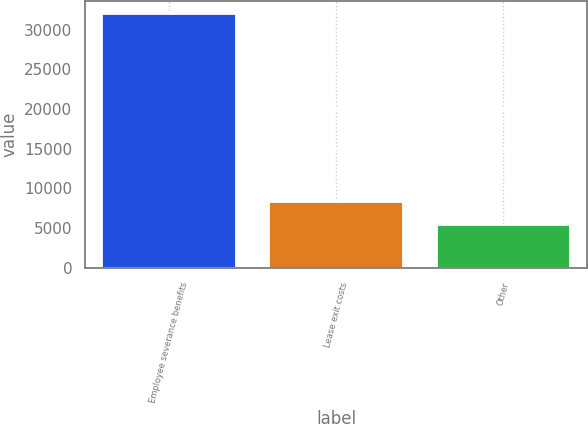Convert chart. <chart><loc_0><loc_0><loc_500><loc_500><bar_chart><fcel>Employee severance benefits<fcel>Lease exit costs<fcel>Other<nl><fcel>32023<fcel>8320<fcel>5362<nl></chart> 